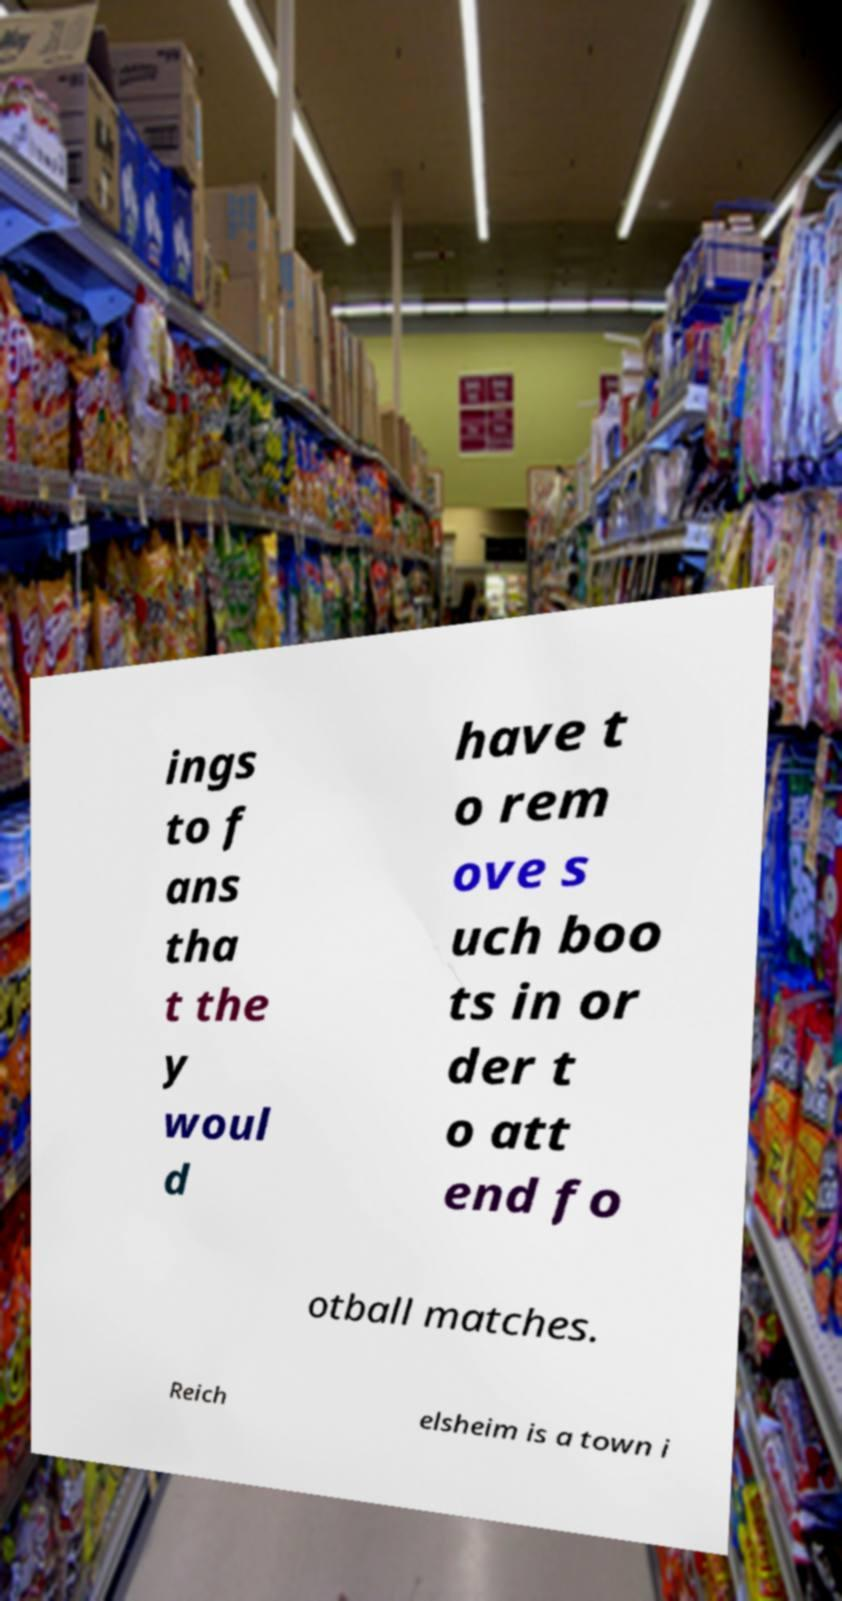Could you extract and type out the text from this image? ings to f ans tha t the y woul d have t o rem ove s uch boo ts in or der t o att end fo otball matches. Reich elsheim is a town i 